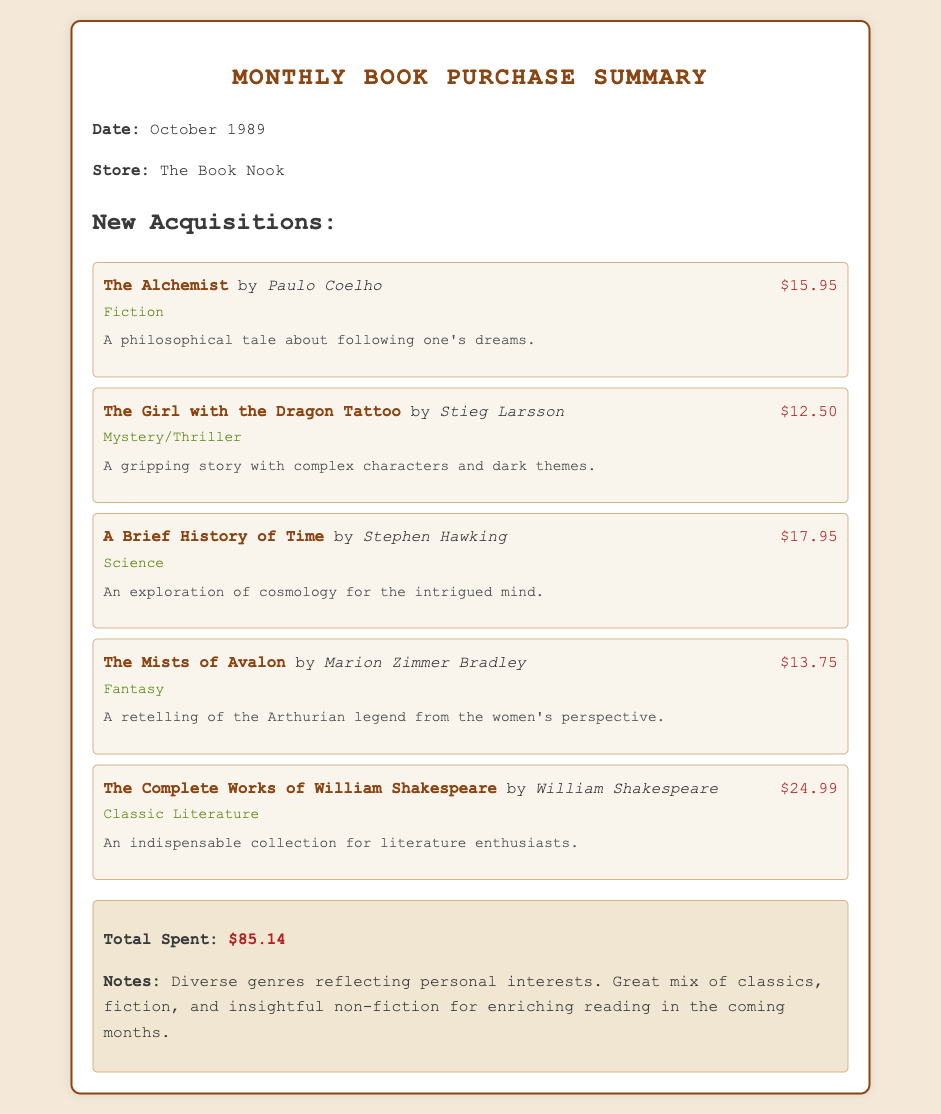What is the date of the summary? The date of the summary is mentioned in the document, which is October 1989.
Answer: October 1989 What is the title of the first book listed? The title of the first book in the new acquisitions section is The Alchemist.
Answer: The Alchemist How much did The Complete Works of William Shakespeare cost? The cost of The Complete Works of William Shakespeare is provided in the document as $24.99.
Answer: $24.99 What genre does A Brief History of Time belong to? The genre classification for A Brief History of Time is listed as Science.
Answer: Science What is the total amount spent on books? The total spent amount is summarized at the end of the document, which is $85.14.
Answer: $85.14 What is the reason for purchasing The Mists of Avalon? The document includes a reason for purchasing The Mists of Avalon, stating it is a retelling of the Arthurian legend from the women's perspective.
Answer: A retelling of the Arthurian legend from the women's perspective How many books are listed under New Acquisitions? The document enumerates the new acquisitions, showing a total of five books.
Answer: Five What genre is represented by the book The Girl with the Dragon Tattoo? The genre for The Girl with the Dragon Tattoo is classified as Mystery/Thriller.
Answer: Mystery/Thriller What is the color of the background in the document? The background color of the document is specified as #f4e9d8.
Answer: #f4e9d8 